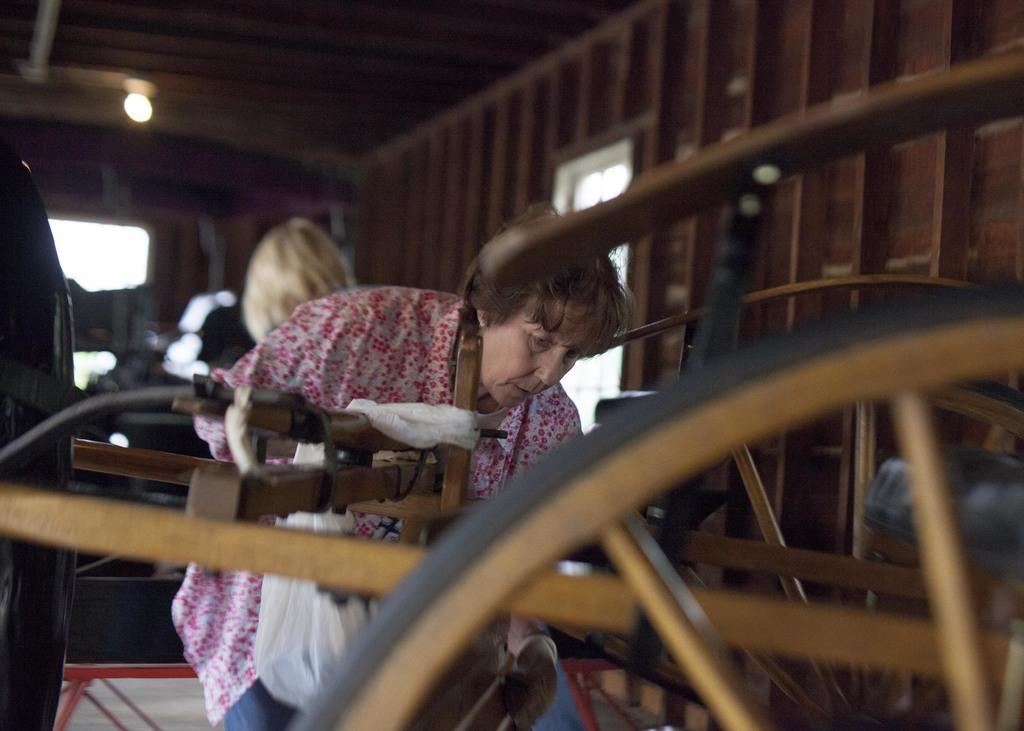How would you summarize this image in a sentence or two? In this image we can see a wheel, wooden object, cover bag on a wooden object. We can see a woman. In the background we can see a person head, light on the ceiling, windows and other objects. 